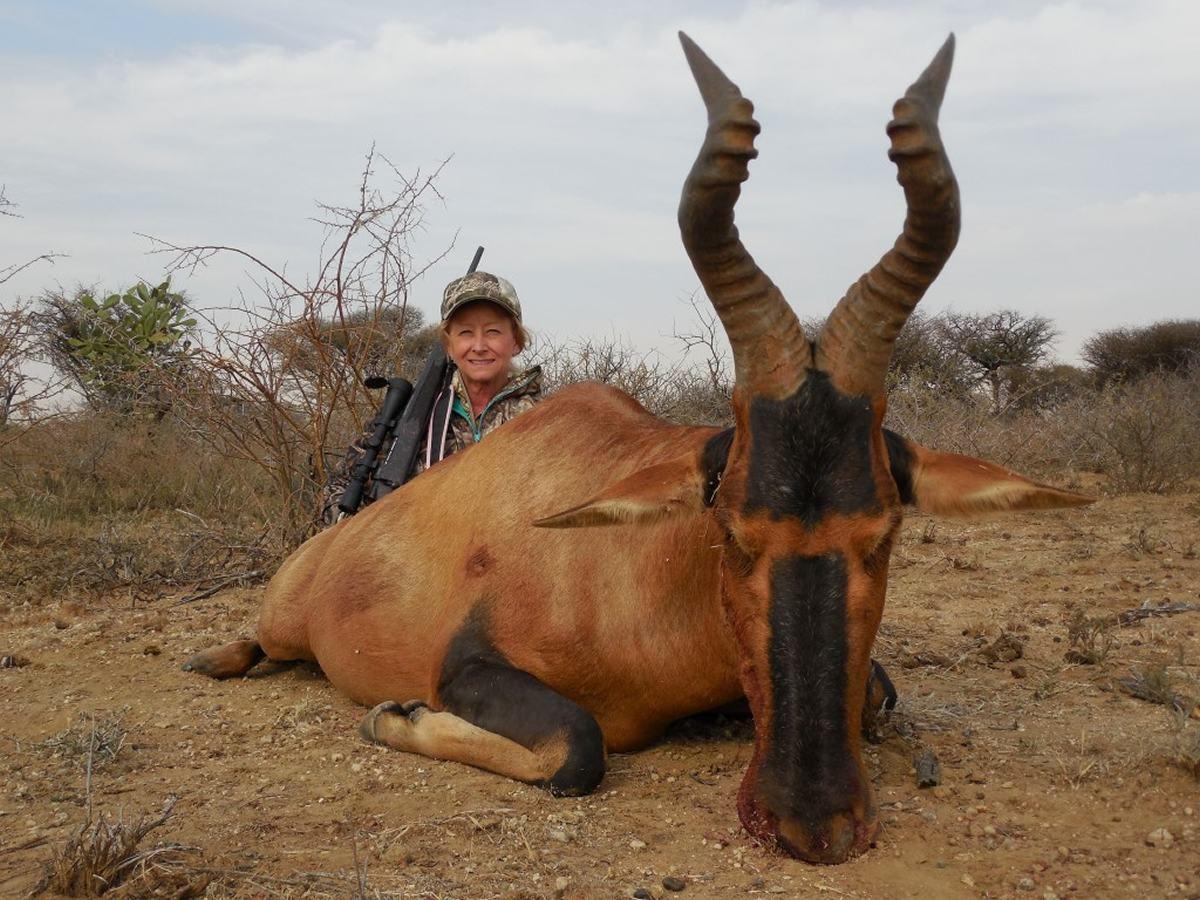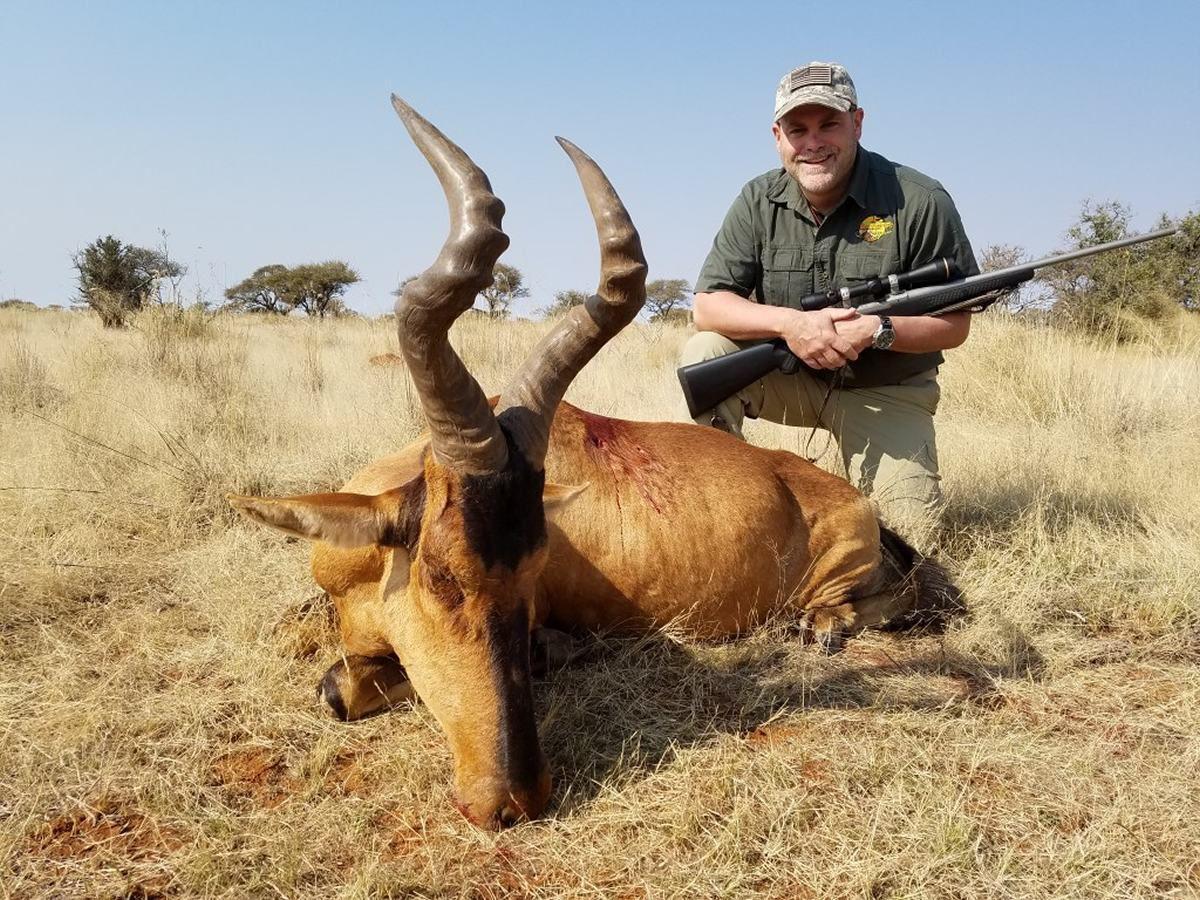The first image is the image on the left, the second image is the image on the right. Assess this claim about the two images: "One of the animals has a red circle on it.". Correct or not? Answer yes or no. No. 